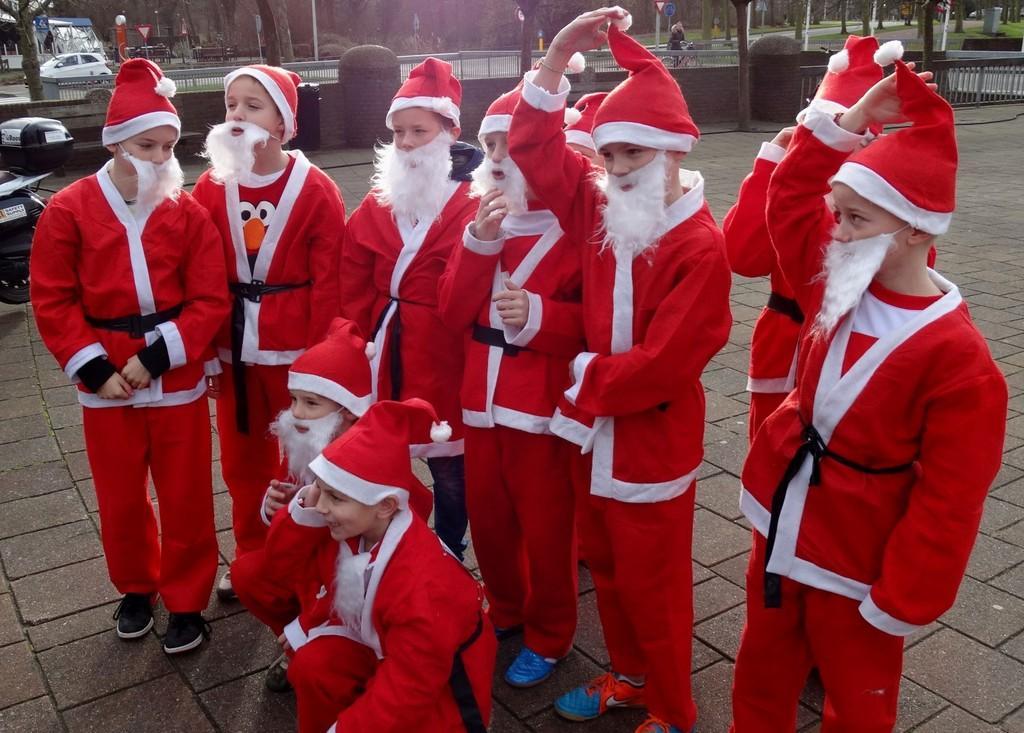Can you describe this image briefly? In this image we can see a crowd standing and sitting on the floor by wearing Santa Claus costumes. In the background there are motor vehicles on the road, person riding bicycle, street poles, sign boards and trees. 